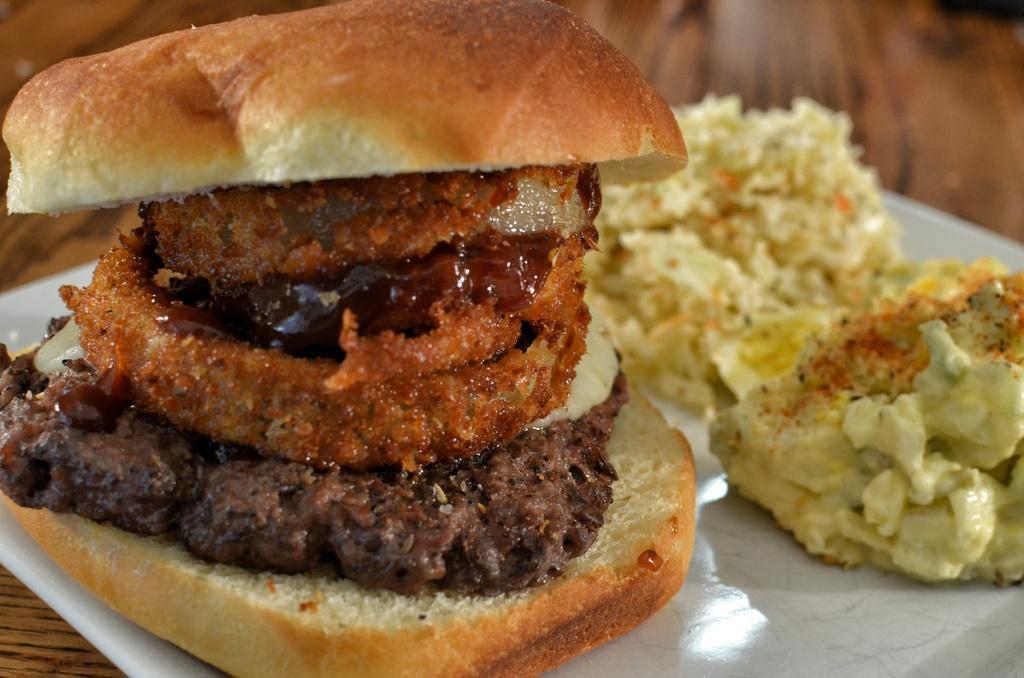Could you give a brief overview of what you see in this image? In this image, there is a plate on the table contains some food. 